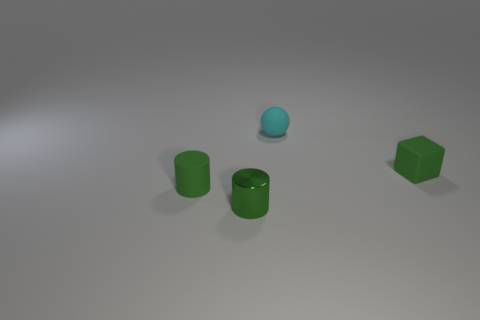Is the color of the tiny ball the same as the metallic thing?
Your answer should be compact. No. Are there more small cyan balls that are right of the small cyan matte ball than tiny green things?
Provide a succinct answer. No. There is another tiny green object that is the same shape as the tiny metallic thing; what is it made of?
Make the answer very short. Rubber. How many green objects are either tiny metallic cylinders or blocks?
Make the answer very short. 2. There is a small thing that is to the left of the metal cylinder; what material is it?
Provide a short and direct response. Rubber. Are there more cyan balls than tiny blue matte cylinders?
Ensure brevity in your answer.  Yes. Do the green matte object to the left of the tiny cyan ball and the small metal object have the same shape?
Give a very brief answer. Yes. What number of rubber objects are both in front of the cyan rubber thing and to the left of the small block?
Your answer should be compact. 1. How many brown metallic things have the same shape as the tiny green shiny thing?
Provide a succinct answer. 0. What is the color of the small cylinder in front of the green matte object left of the block?
Offer a very short reply. Green. 